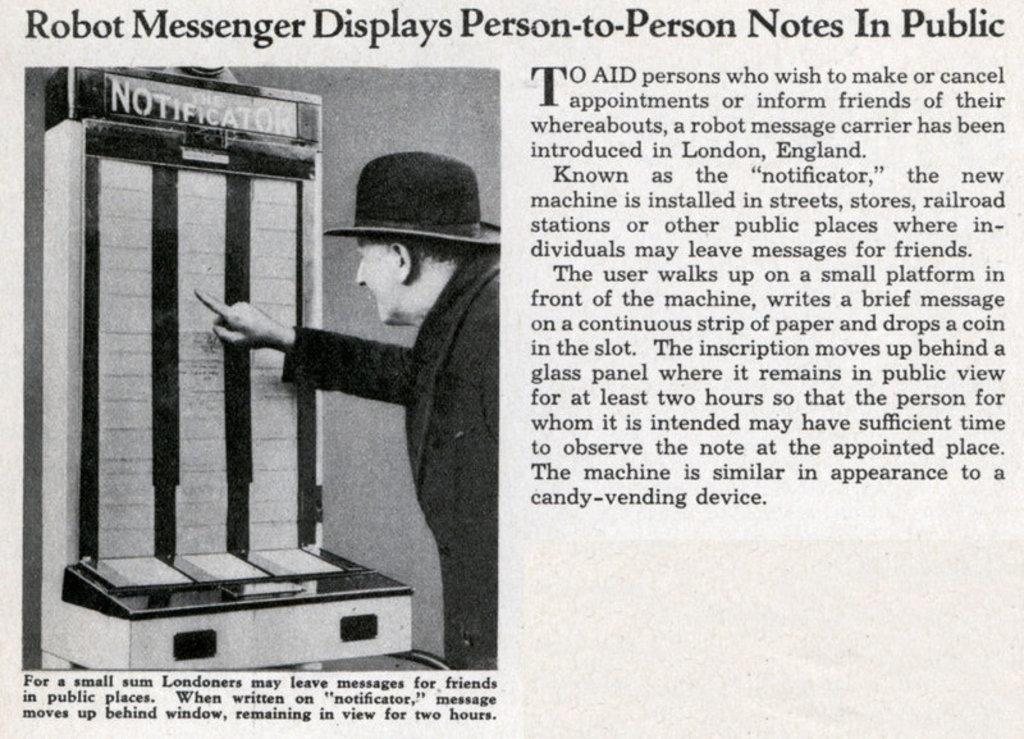What is the main subject of the paper in the image? The paper contains an image of a person with a hat. What is the person in the image holding? There is an object in front of the person in the image. Can you describe the text on the paper? There is text written on the paper. What type of stem can be seen growing from the pancake in the image? There is no pancake or stem present in the image. 